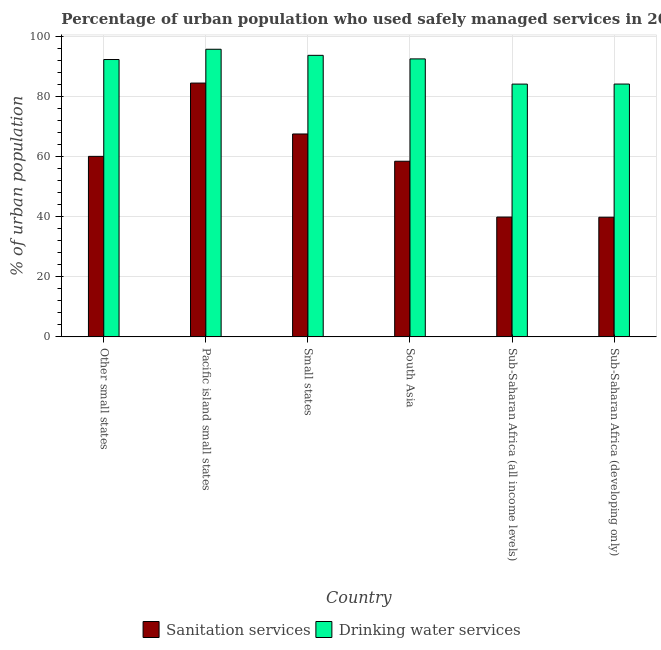How many different coloured bars are there?
Your response must be concise. 2. How many groups of bars are there?
Provide a short and direct response. 6. Are the number of bars per tick equal to the number of legend labels?
Keep it short and to the point. Yes. Are the number of bars on each tick of the X-axis equal?
Give a very brief answer. Yes. How many bars are there on the 5th tick from the left?
Keep it short and to the point. 2. How many bars are there on the 4th tick from the right?
Provide a short and direct response. 2. What is the label of the 6th group of bars from the left?
Your answer should be very brief. Sub-Saharan Africa (developing only). What is the percentage of urban population who used drinking water services in Pacific island small states?
Offer a very short reply. 95.84. Across all countries, what is the maximum percentage of urban population who used sanitation services?
Your response must be concise. 84.57. Across all countries, what is the minimum percentage of urban population who used sanitation services?
Provide a succinct answer. 39.87. In which country was the percentage of urban population who used drinking water services maximum?
Keep it short and to the point. Pacific island small states. In which country was the percentage of urban population who used drinking water services minimum?
Your response must be concise. Sub-Saharan Africa (all income levels). What is the total percentage of urban population who used drinking water services in the graph?
Offer a terse response. 543.18. What is the difference between the percentage of urban population who used drinking water services in Pacific island small states and that in South Asia?
Offer a very short reply. 3.21. What is the difference between the percentage of urban population who used drinking water services in Small states and the percentage of urban population who used sanitation services in South Asia?
Your answer should be very brief. 35.29. What is the average percentage of urban population who used sanitation services per country?
Your response must be concise. 58.44. What is the difference between the percentage of urban population who used sanitation services and percentage of urban population who used drinking water services in Pacific island small states?
Your response must be concise. -11.27. What is the ratio of the percentage of urban population who used sanitation services in Other small states to that in South Asia?
Your answer should be very brief. 1.03. Is the difference between the percentage of urban population who used sanitation services in Small states and Sub-Saharan Africa (developing only) greater than the difference between the percentage of urban population who used drinking water services in Small states and Sub-Saharan Africa (developing only)?
Provide a short and direct response. Yes. What is the difference between the highest and the second highest percentage of urban population who used drinking water services?
Give a very brief answer. 2.03. What is the difference between the highest and the lowest percentage of urban population who used drinking water services?
Offer a very short reply. 11.61. Is the sum of the percentage of urban population who used drinking water services in Pacific island small states and Sub-Saharan Africa (developing only) greater than the maximum percentage of urban population who used sanitation services across all countries?
Your answer should be very brief. Yes. What does the 2nd bar from the left in Sub-Saharan Africa (developing only) represents?
Make the answer very short. Drinking water services. What does the 2nd bar from the right in Sub-Saharan Africa (developing only) represents?
Your answer should be very brief. Sanitation services. Are all the bars in the graph horizontal?
Ensure brevity in your answer.  No. Are the values on the major ticks of Y-axis written in scientific E-notation?
Your answer should be very brief. No. Does the graph contain grids?
Your answer should be very brief. Yes. How many legend labels are there?
Keep it short and to the point. 2. How are the legend labels stacked?
Offer a terse response. Horizontal. What is the title of the graph?
Your answer should be compact. Percentage of urban population who used safely managed services in 2004. What is the label or title of the X-axis?
Make the answer very short. Country. What is the label or title of the Y-axis?
Offer a very short reply. % of urban population. What is the % of urban population in Sanitation services in Other small states?
Make the answer very short. 60.15. What is the % of urban population of Drinking water services in Other small states?
Provide a succinct answer. 92.42. What is the % of urban population in Sanitation services in Pacific island small states?
Offer a terse response. 84.57. What is the % of urban population in Drinking water services in Pacific island small states?
Give a very brief answer. 95.84. What is the % of urban population in Sanitation services in Small states?
Your answer should be compact. 67.61. What is the % of urban population of Drinking water services in Small states?
Provide a succinct answer. 93.82. What is the % of urban population in Sanitation services in South Asia?
Give a very brief answer. 58.52. What is the % of urban population of Drinking water services in South Asia?
Provide a succinct answer. 92.63. What is the % of urban population in Sanitation services in Sub-Saharan Africa (all income levels)?
Ensure brevity in your answer.  39.92. What is the % of urban population of Drinking water services in Sub-Saharan Africa (all income levels)?
Offer a very short reply. 84.23. What is the % of urban population of Sanitation services in Sub-Saharan Africa (developing only)?
Provide a short and direct response. 39.87. What is the % of urban population in Drinking water services in Sub-Saharan Africa (developing only)?
Ensure brevity in your answer.  84.25. Across all countries, what is the maximum % of urban population of Sanitation services?
Your response must be concise. 84.57. Across all countries, what is the maximum % of urban population in Drinking water services?
Ensure brevity in your answer.  95.84. Across all countries, what is the minimum % of urban population in Sanitation services?
Your response must be concise. 39.87. Across all countries, what is the minimum % of urban population of Drinking water services?
Your answer should be compact. 84.23. What is the total % of urban population in Sanitation services in the graph?
Give a very brief answer. 350.64. What is the total % of urban population in Drinking water services in the graph?
Offer a very short reply. 543.18. What is the difference between the % of urban population of Sanitation services in Other small states and that in Pacific island small states?
Offer a terse response. -24.42. What is the difference between the % of urban population of Drinking water services in Other small states and that in Pacific island small states?
Provide a succinct answer. -3.42. What is the difference between the % of urban population of Sanitation services in Other small states and that in Small states?
Offer a very short reply. -7.46. What is the difference between the % of urban population in Drinking water services in Other small states and that in Small states?
Provide a short and direct response. -1.4. What is the difference between the % of urban population in Sanitation services in Other small states and that in South Asia?
Give a very brief answer. 1.62. What is the difference between the % of urban population of Drinking water services in Other small states and that in South Asia?
Offer a terse response. -0.21. What is the difference between the % of urban population of Sanitation services in Other small states and that in Sub-Saharan Africa (all income levels)?
Your answer should be compact. 20.23. What is the difference between the % of urban population of Drinking water services in Other small states and that in Sub-Saharan Africa (all income levels)?
Your answer should be compact. 8.19. What is the difference between the % of urban population in Sanitation services in Other small states and that in Sub-Saharan Africa (developing only)?
Keep it short and to the point. 20.28. What is the difference between the % of urban population in Drinking water services in Other small states and that in Sub-Saharan Africa (developing only)?
Ensure brevity in your answer.  8.17. What is the difference between the % of urban population of Sanitation services in Pacific island small states and that in Small states?
Provide a short and direct response. 16.96. What is the difference between the % of urban population in Drinking water services in Pacific island small states and that in Small states?
Your answer should be compact. 2.03. What is the difference between the % of urban population in Sanitation services in Pacific island small states and that in South Asia?
Ensure brevity in your answer.  26.05. What is the difference between the % of urban population in Drinking water services in Pacific island small states and that in South Asia?
Your answer should be very brief. 3.21. What is the difference between the % of urban population in Sanitation services in Pacific island small states and that in Sub-Saharan Africa (all income levels)?
Your answer should be compact. 44.65. What is the difference between the % of urban population in Drinking water services in Pacific island small states and that in Sub-Saharan Africa (all income levels)?
Keep it short and to the point. 11.61. What is the difference between the % of urban population of Sanitation services in Pacific island small states and that in Sub-Saharan Africa (developing only)?
Provide a succinct answer. 44.7. What is the difference between the % of urban population of Drinking water services in Pacific island small states and that in Sub-Saharan Africa (developing only)?
Ensure brevity in your answer.  11.59. What is the difference between the % of urban population in Sanitation services in Small states and that in South Asia?
Your answer should be compact. 9.09. What is the difference between the % of urban population in Drinking water services in Small states and that in South Asia?
Provide a short and direct response. 1.19. What is the difference between the % of urban population of Sanitation services in Small states and that in Sub-Saharan Africa (all income levels)?
Your answer should be compact. 27.69. What is the difference between the % of urban population of Drinking water services in Small states and that in Sub-Saharan Africa (all income levels)?
Offer a very short reply. 9.59. What is the difference between the % of urban population of Sanitation services in Small states and that in Sub-Saharan Africa (developing only)?
Keep it short and to the point. 27.74. What is the difference between the % of urban population in Drinking water services in Small states and that in Sub-Saharan Africa (developing only)?
Provide a succinct answer. 9.57. What is the difference between the % of urban population of Sanitation services in South Asia and that in Sub-Saharan Africa (all income levels)?
Your answer should be compact. 18.6. What is the difference between the % of urban population of Drinking water services in South Asia and that in Sub-Saharan Africa (all income levels)?
Provide a succinct answer. 8.4. What is the difference between the % of urban population of Sanitation services in South Asia and that in Sub-Saharan Africa (developing only)?
Give a very brief answer. 18.65. What is the difference between the % of urban population of Drinking water services in South Asia and that in Sub-Saharan Africa (developing only)?
Your answer should be very brief. 8.38. What is the difference between the % of urban population in Sanitation services in Sub-Saharan Africa (all income levels) and that in Sub-Saharan Africa (developing only)?
Offer a terse response. 0.05. What is the difference between the % of urban population of Drinking water services in Sub-Saharan Africa (all income levels) and that in Sub-Saharan Africa (developing only)?
Keep it short and to the point. -0.02. What is the difference between the % of urban population in Sanitation services in Other small states and the % of urban population in Drinking water services in Pacific island small states?
Your response must be concise. -35.69. What is the difference between the % of urban population of Sanitation services in Other small states and the % of urban population of Drinking water services in Small states?
Your answer should be very brief. -33.67. What is the difference between the % of urban population of Sanitation services in Other small states and the % of urban population of Drinking water services in South Asia?
Offer a very short reply. -32.48. What is the difference between the % of urban population in Sanitation services in Other small states and the % of urban population in Drinking water services in Sub-Saharan Africa (all income levels)?
Offer a terse response. -24.08. What is the difference between the % of urban population of Sanitation services in Other small states and the % of urban population of Drinking water services in Sub-Saharan Africa (developing only)?
Give a very brief answer. -24.1. What is the difference between the % of urban population of Sanitation services in Pacific island small states and the % of urban population of Drinking water services in Small states?
Ensure brevity in your answer.  -9.24. What is the difference between the % of urban population in Sanitation services in Pacific island small states and the % of urban population in Drinking water services in South Asia?
Keep it short and to the point. -8.06. What is the difference between the % of urban population of Sanitation services in Pacific island small states and the % of urban population of Drinking water services in Sub-Saharan Africa (all income levels)?
Your answer should be compact. 0.34. What is the difference between the % of urban population of Sanitation services in Pacific island small states and the % of urban population of Drinking water services in Sub-Saharan Africa (developing only)?
Your answer should be compact. 0.32. What is the difference between the % of urban population of Sanitation services in Small states and the % of urban population of Drinking water services in South Asia?
Ensure brevity in your answer.  -25.02. What is the difference between the % of urban population of Sanitation services in Small states and the % of urban population of Drinking water services in Sub-Saharan Africa (all income levels)?
Offer a very short reply. -16.62. What is the difference between the % of urban population of Sanitation services in Small states and the % of urban population of Drinking water services in Sub-Saharan Africa (developing only)?
Give a very brief answer. -16.64. What is the difference between the % of urban population in Sanitation services in South Asia and the % of urban population in Drinking water services in Sub-Saharan Africa (all income levels)?
Your response must be concise. -25.7. What is the difference between the % of urban population in Sanitation services in South Asia and the % of urban population in Drinking water services in Sub-Saharan Africa (developing only)?
Make the answer very short. -25.72. What is the difference between the % of urban population of Sanitation services in Sub-Saharan Africa (all income levels) and the % of urban population of Drinking water services in Sub-Saharan Africa (developing only)?
Ensure brevity in your answer.  -44.33. What is the average % of urban population in Sanitation services per country?
Give a very brief answer. 58.44. What is the average % of urban population of Drinking water services per country?
Your answer should be compact. 90.53. What is the difference between the % of urban population in Sanitation services and % of urban population in Drinking water services in Other small states?
Your response must be concise. -32.27. What is the difference between the % of urban population in Sanitation services and % of urban population in Drinking water services in Pacific island small states?
Make the answer very short. -11.27. What is the difference between the % of urban population in Sanitation services and % of urban population in Drinking water services in Small states?
Your response must be concise. -26.21. What is the difference between the % of urban population of Sanitation services and % of urban population of Drinking water services in South Asia?
Provide a succinct answer. -34.1. What is the difference between the % of urban population in Sanitation services and % of urban population in Drinking water services in Sub-Saharan Africa (all income levels)?
Your answer should be compact. -44.31. What is the difference between the % of urban population in Sanitation services and % of urban population in Drinking water services in Sub-Saharan Africa (developing only)?
Provide a succinct answer. -44.38. What is the ratio of the % of urban population of Sanitation services in Other small states to that in Pacific island small states?
Provide a short and direct response. 0.71. What is the ratio of the % of urban population of Drinking water services in Other small states to that in Pacific island small states?
Provide a short and direct response. 0.96. What is the ratio of the % of urban population of Sanitation services in Other small states to that in Small states?
Provide a succinct answer. 0.89. What is the ratio of the % of urban population of Drinking water services in Other small states to that in Small states?
Give a very brief answer. 0.99. What is the ratio of the % of urban population in Sanitation services in Other small states to that in South Asia?
Your answer should be very brief. 1.03. What is the ratio of the % of urban population of Drinking water services in Other small states to that in South Asia?
Offer a terse response. 1. What is the ratio of the % of urban population of Sanitation services in Other small states to that in Sub-Saharan Africa (all income levels)?
Offer a very short reply. 1.51. What is the ratio of the % of urban population of Drinking water services in Other small states to that in Sub-Saharan Africa (all income levels)?
Provide a succinct answer. 1.1. What is the ratio of the % of urban population of Sanitation services in Other small states to that in Sub-Saharan Africa (developing only)?
Your response must be concise. 1.51. What is the ratio of the % of urban population of Drinking water services in Other small states to that in Sub-Saharan Africa (developing only)?
Offer a very short reply. 1.1. What is the ratio of the % of urban population of Sanitation services in Pacific island small states to that in Small states?
Make the answer very short. 1.25. What is the ratio of the % of urban population of Drinking water services in Pacific island small states to that in Small states?
Ensure brevity in your answer.  1.02. What is the ratio of the % of urban population of Sanitation services in Pacific island small states to that in South Asia?
Offer a terse response. 1.45. What is the ratio of the % of urban population of Drinking water services in Pacific island small states to that in South Asia?
Give a very brief answer. 1.03. What is the ratio of the % of urban population in Sanitation services in Pacific island small states to that in Sub-Saharan Africa (all income levels)?
Your answer should be very brief. 2.12. What is the ratio of the % of urban population of Drinking water services in Pacific island small states to that in Sub-Saharan Africa (all income levels)?
Ensure brevity in your answer.  1.14. What is the ratio of the % of urban population of Sanitation services in Pacific island small states to that in Sub-Saharan Africa (developing only)?
Provide a succinct answer. 2.12. What is the ratio of the % of urban population of Drinking water services in Pacific island small states to that in Sub-Saharan Africa (developing only)?
Provide a short and direct response. 1.14. What is the ratio of the % of urban population in Sanitation services in Small states to that in South Asia?
Your answer should be very brief. 1.16. What is the ratio of the % of urban population in Drinking water services in Small states to that in South Asia?
Ensure brevity in your answer.  1.01. What is the ratio of the % of urban population in Sanitation services in Small states to that in Sub-Saharan Africa (all income levels)?
Your answer should be compact. 1.69. What is the ratio of the % of urban population in Drinking water services in Small states to that in Sub-Saharan Africa (all income levels)?
Ensure brevity in your answer.  1.11. What is the ratio of the % of urban population of Sanitation services in Small states to that in Sub-Saharan Africa (developing only)?
Keep it short and to the point. 1.7. What is the ratio of the % of urban population in Drinking water services in Small states to that in Sub-Saharan Africa (developing only)?
Make the answer very short. 1.11. What is the ratio of the % of urban population of Sanitation services in South Asia to that in Sub-Saharan Africa (all income levels)?
Give a very brief answer. 1.47. What is the ratio of the % of urban population in Drinking water services in South Asia to that in Sub-Saharan Africa (all income levels)?
Provide a succinct answer. 1.1. What is the ratio of the % of urban population in Sanitation services in South Asia to that in Sub-Saharan Africa (developing only)?
Offer a very short reply. 1.47. What is the ratio of the % of urban population in Drinking water services in South Asia to that in Sub-Saharan Africa (developing only)?
Ensure brevity in your answer.  1.1. What is the ratio of the % of urban population of Sanitation services in Sub-Saharan Africa (all income levels) to that in Sub-Saharan Africa (developing only)?
Give a very brief answer. 1. What is the difference between the highest and the second highest % of urban population in Sanitation services?
Make the answer very short. 16.96. What is the difference between the highest and the second highest % of urban population of Drinking water services?
Your answer should be very brief. 2.03. What is the difference between the highest and the lowest % of urban population of Sanitation services?
Your answer should be compact. 44.7. What is the difference between the highest and the lowest % of urban population in Drinking water services?
Offer a very short reply. 11.61. 